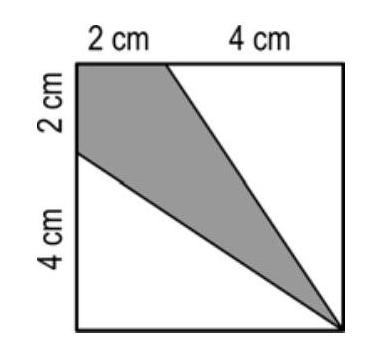What geometric shapes are visible in the grey region? The grey area within the square forms two triangles. Each triangle shares one edge with the square and intersects at a diagonal, giving them a right triangle appearance. 